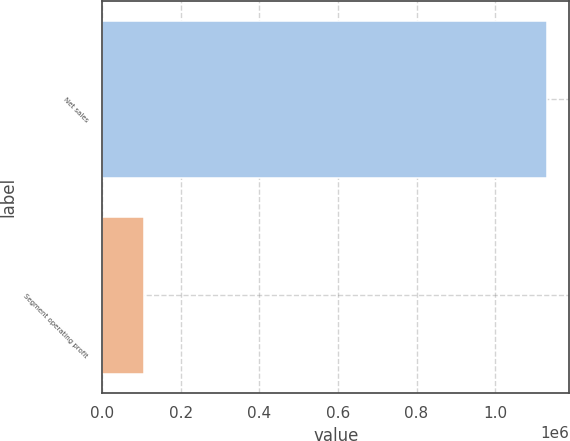<chart> <loc_0><loc_0><loc_500><loc_500><bar_chart><fcel>Net sales<fcel>Segment operating profit<nl><fcel>1.13264e+06<fcel>105515<nl></chart> 